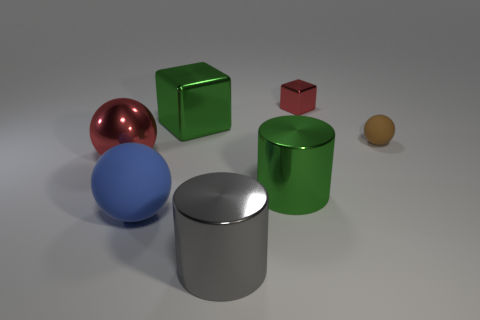Add 3 big yellow metallic balls. How many objects exist? 10 Subtract all cylinders. How many objects are left? 5 Subtract all large blue metal blocks. Subtract all large rubber objects. How many objects are left? 6 Add 4 metallic spheres. How many metallic spheres are left? 5 Add 6 small brown matte objects. How many small brown matte objects exist? 7 Subtract 1 gray cylinders. How many objects are left? 6 